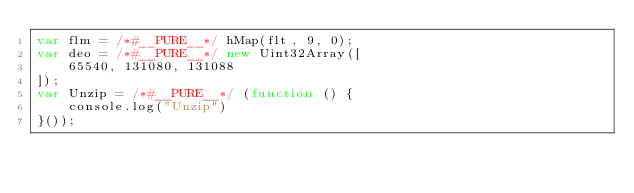<code> <loc_0><loc_0><loc_500><loc_500><_JavaScript_>var flm = /*#__PURE__*/ hMap(flt, 9, 0);
var deo = /*#__PURE__*/ new Uint32Array([
    65540, 131080, 131088
]);
var Unzip = /*#__PURE__*/ (function () {
    console.log("Unzip")
}());</code> 